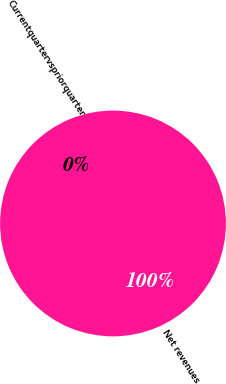<chart> <loc_0><loc_0><loc_500><loc_500><pie_chart><fcel>Net revenues<fcel>Currentquartervspriorquarter<nl><fcel>100.0%<fcel>0.0%<nl></chart> 